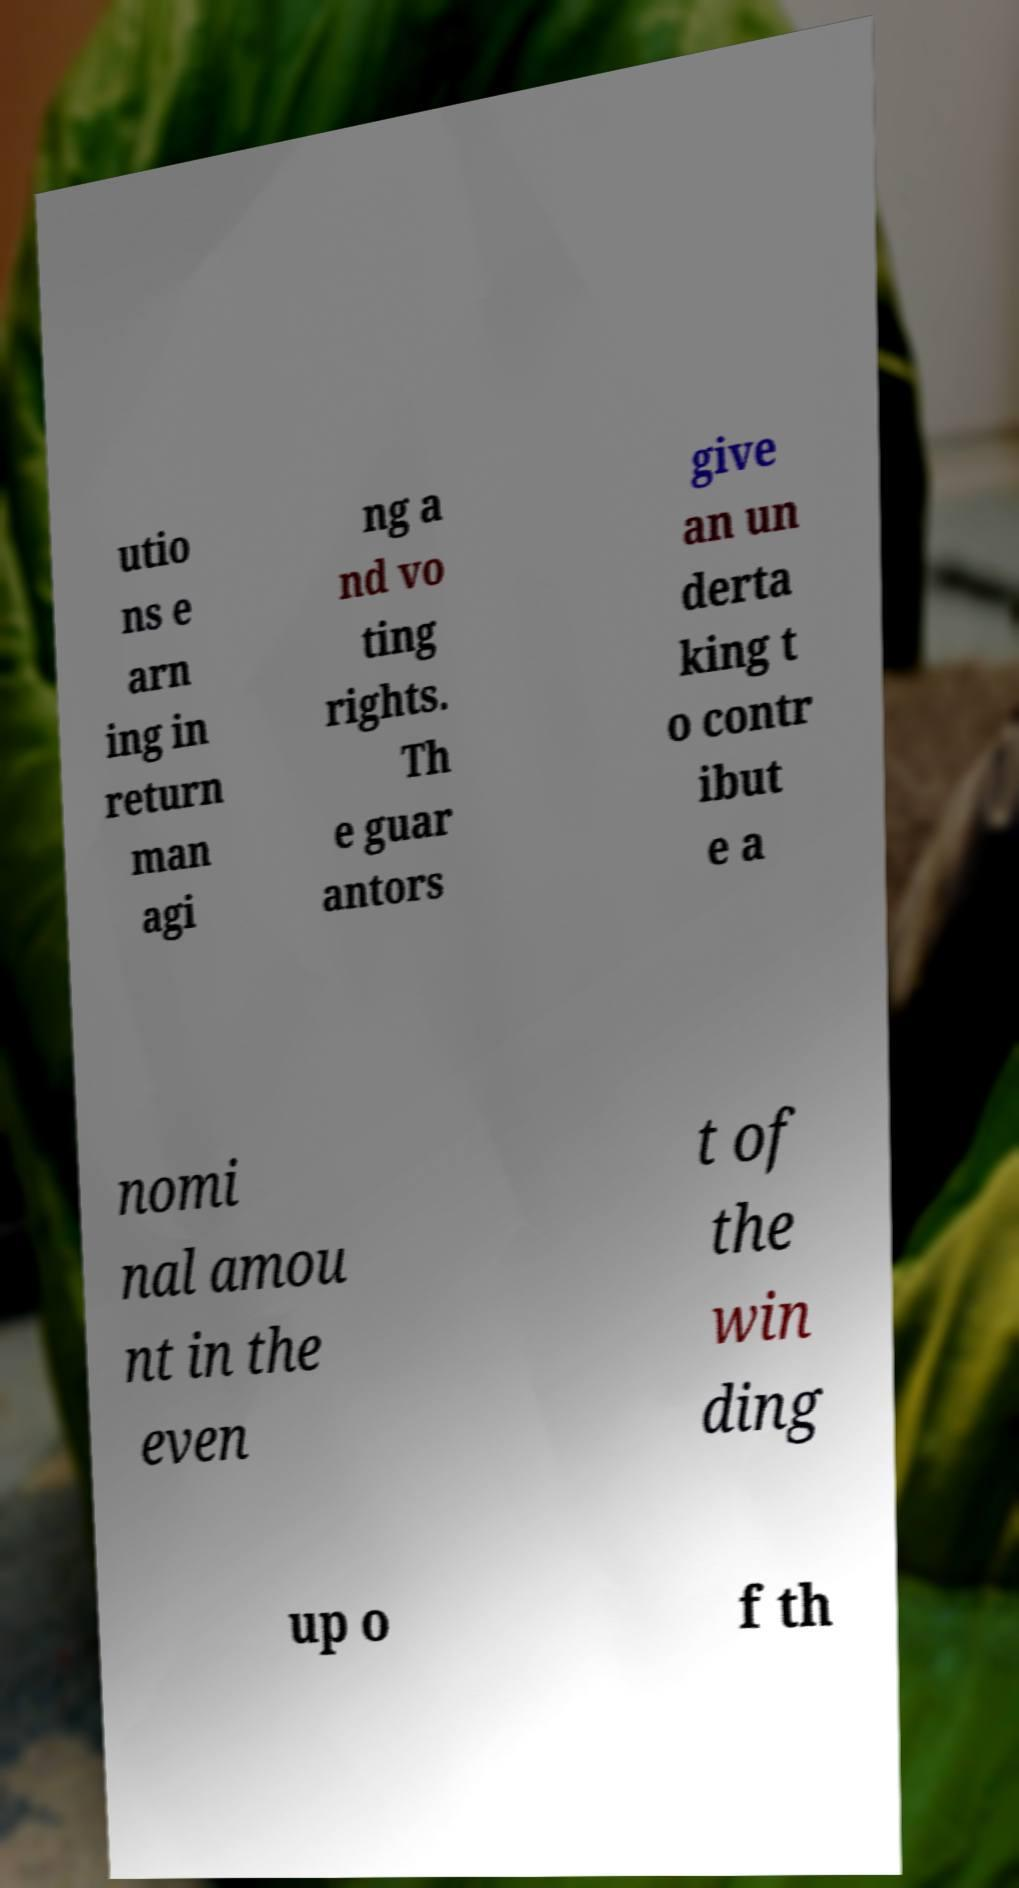Please read and relay the text visible in this image. What does it say? utio ns e arn ing in return man agi ng a nd vo ting rights. Th e guar antors give an un derta king t o contr ibut e a nomi nal amou nt in the even t of the win ding up o f th 